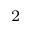Convert formula to latex. <formula><loc_0><loc_0><loc_500><loc_500>^ { 2 }</formula> 